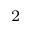Convert formula to latex. <formula><loc_0><loc_0><loc_500><loc_500>^ { 2 }</formula> 